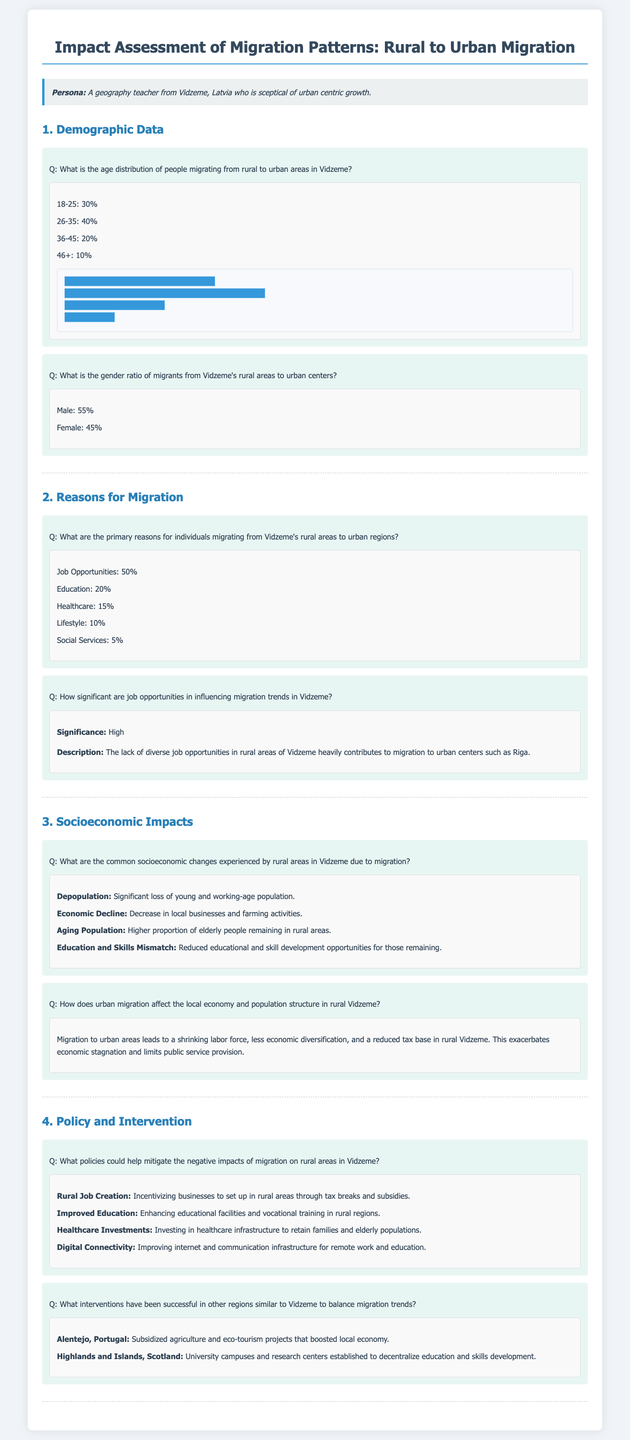What is the age group with the highest percentage of migrants? The age distribution table shows that the age group 26-35 has the highest percentage of migrants at 40%.
Answer: 26-35 What is the gender ratio of male migrants from Vidzeme? According to the document, the gender ratio indicates that male migrants account for 55%.
Answer: 55% What percentage of migrants cited job opportunities as the reason for migration? The information states that 50% of individuals migrated due to job opportunities.
Answer: 50% What socioeconomic impact is described as a significant loss in Vidzeme? The document highlights depopulation as a common socioeconomic change experienced due to migration.
Answer: Depopulation What policy is suggested to improve education in rural Vidzeme? The document suggests improving educational facilities and vocational training as a policy to retain the population.
Answer: Improved Education Which region is mentioned in comparison to Vidzeme regarding migration interventions? The document references Alentejo, Portugal, as a successful region similar to Vidzeme for migration interventions.
Answer: Alentejo, Portugal What is the significance level of job opportunities in influencing migration trends in Vidzeme? The document describes the significance of job opportunities in migration trends as high.
Answer: High How does migration affect the tax base in rural Vidzeme? The document states that migration leads to a reduced tax base in rural Vidzeme.
Answer: Reduced tax base 